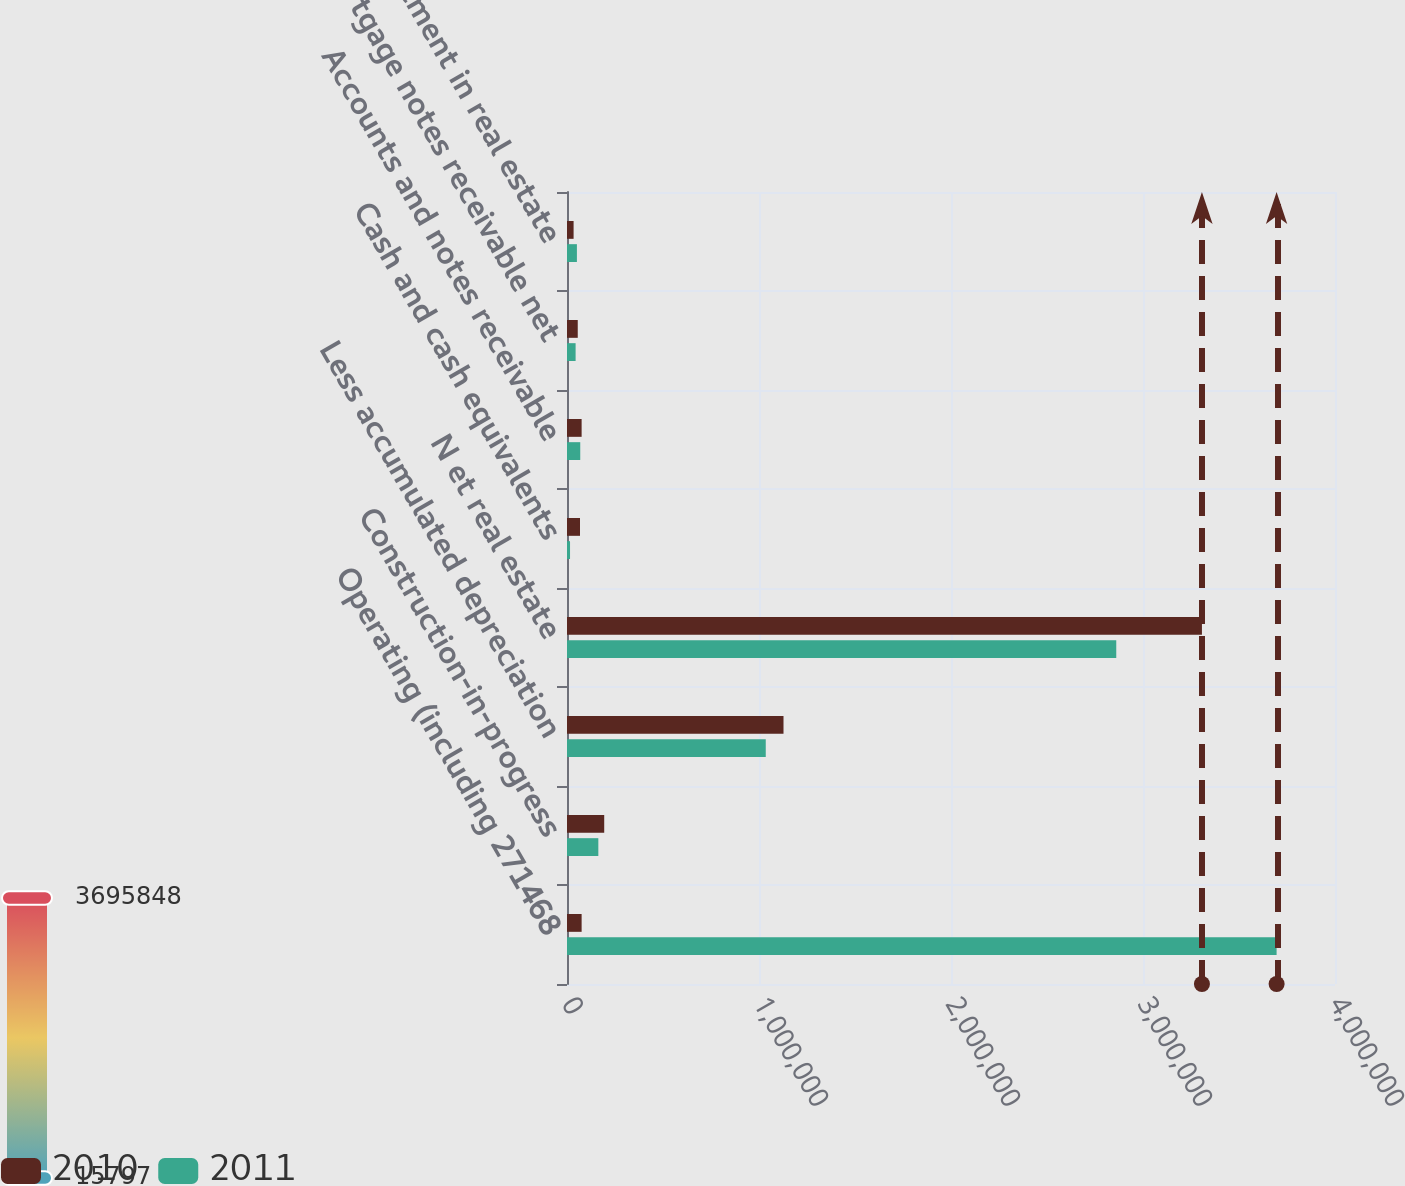Convert chart. <chart><loc_0><loc_0><loc_500><loc_500><stacked_bar_chart><ecel><fcel>Operating (including 271468<fcel>Construction-in-progress<fcel>Less accumulated depreciation<fcel>N et real estate<fcel>Cash and cash equivalents<fcel>Accounts and notes receivable<fcel>Mortgage notes receivable net<fcel>Investment in real estate<nl><fcel>2010<fcel>76152<fcel>193836<fcel>1.12759e+06<fcel>3.30696e+06<fcel>67806<fcel>76152<fcel>55967<fcel>34352<nl><fcel>2011<fcel>3.69585e+06<fcel>163200<fcel>1.0352e+06<fcel>2.86074e+06<fcel>15797<fcel>68997<fcel>44813<fcel>51606<nl></chart> 